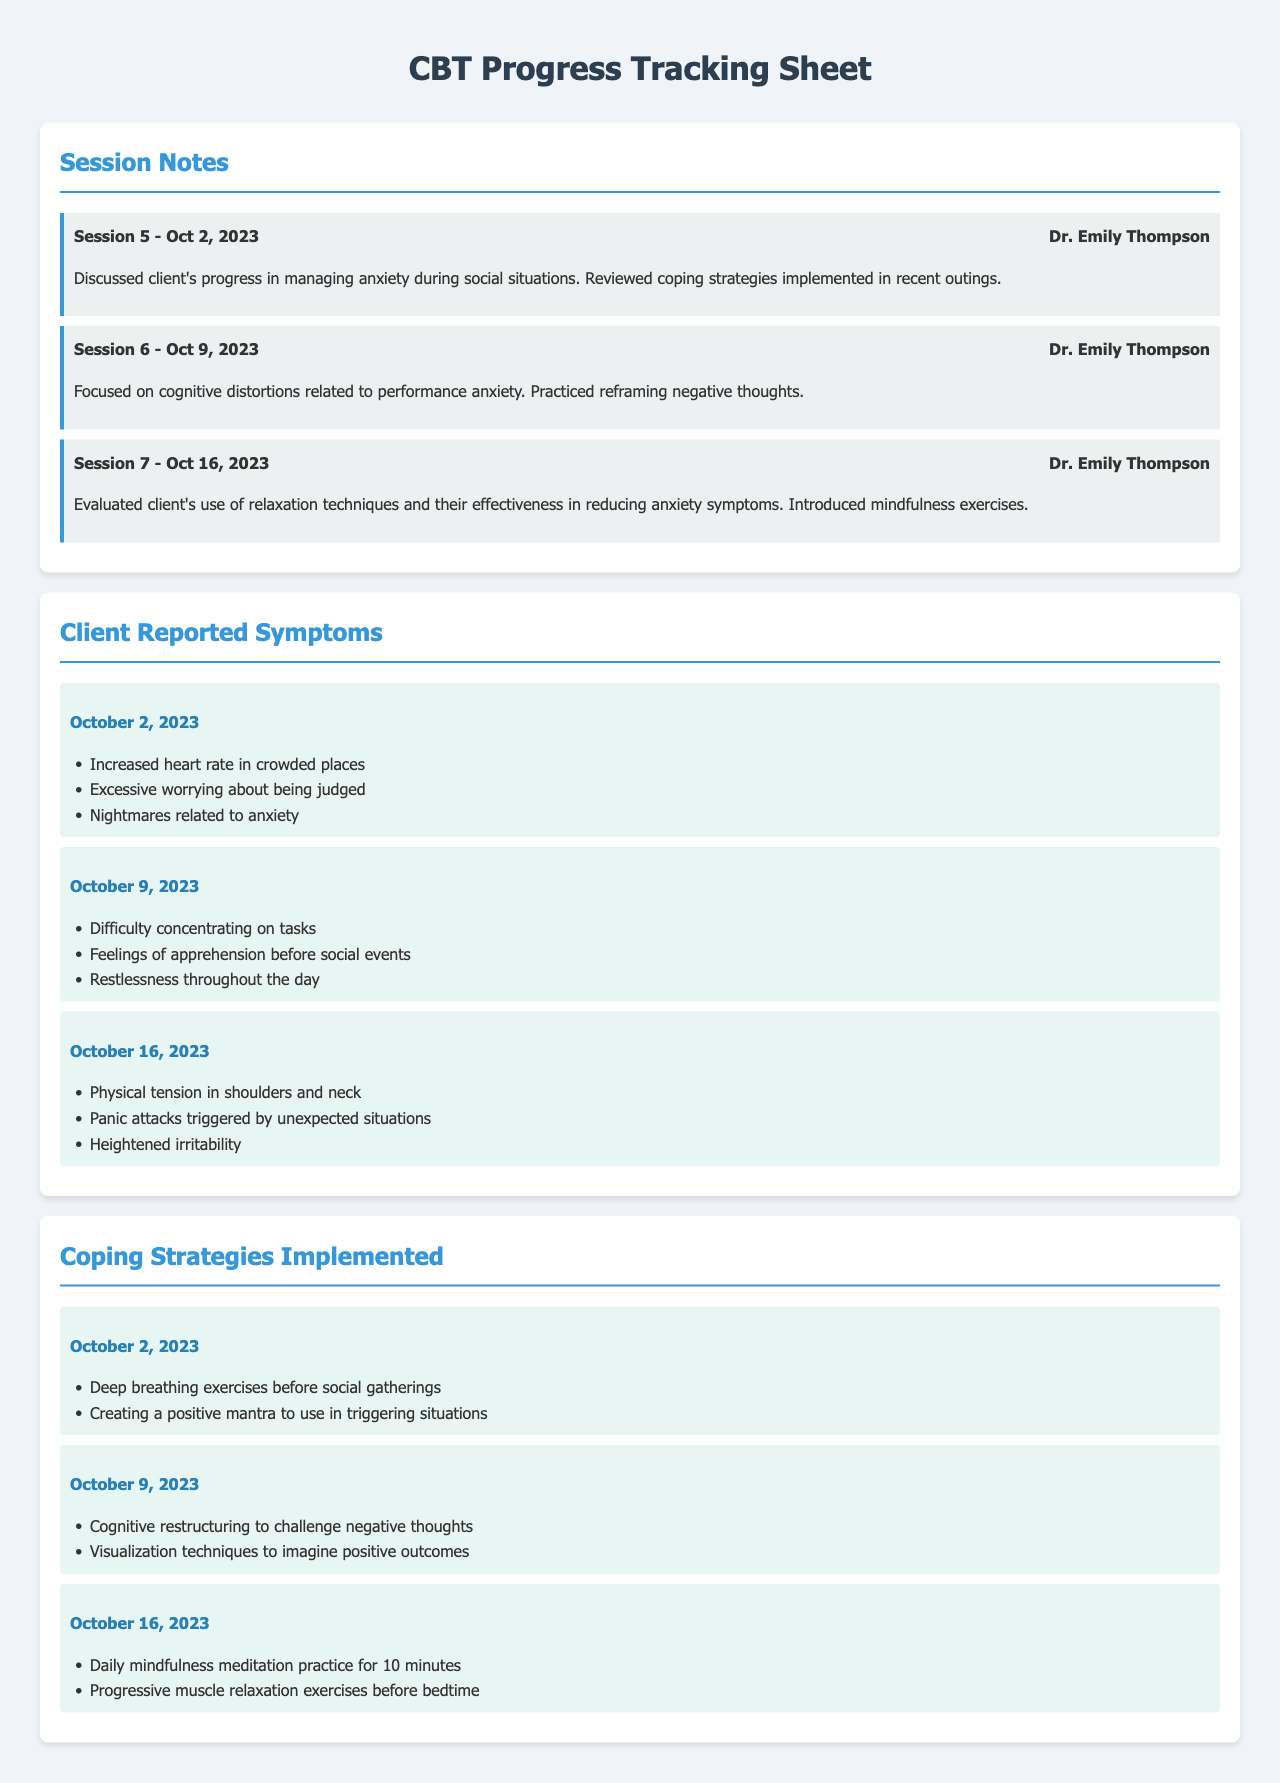What is the date of Session 5? The date of Session 5 is explicitly mentioned in the session notes section as October 2, 2023.
Answer: October 2, 2023 Who is the therapist for all recorded sessions? The document lists Dr. Emily Thompson as the therapist for every session noted, making her the consistent practitioner.
Answer: Dr. Emily Thompson What symptom was reported on October 9, 2023? The symptoms section includes specific reported symptoms for each date, including "Difficulty concentrating on tasks" for October 9, 2023.
Answer: Difficulty concentrating on tasks What coping strategy was implemented on October 16, 2023? The coping strategies section shows each date along with corresponding strategies; on October 16, 2023, one of the strategies is "Daily mindfulness meditation practice for 10 minutes."
Answer: Daily mindfulness meditation practice for 10 minutes How many sessions are documented in total? The document lists three sessions, as indicated in the session notes section.
Answer: Three Which symptom reflects physical discomfort on October 16, 2023? Among the symptoms listed for October 16, 2023, "Physical tension in shoulders and neck" explicitly indicates physical discomfort.
Answer: Physical tension in shoulders and neck What was the focus of the sixth session? The sixth session's focus as noted in the session notes portion revolves around cognitive distortions associated with performance anxiety.
Answer: Cognitive distortions related to performance anxiety How many coping strategies were listed for October 9, 2023? The coping strategies section for October 9, 2023, includes two strategies, thus providing a clear count.
Answer: Two 